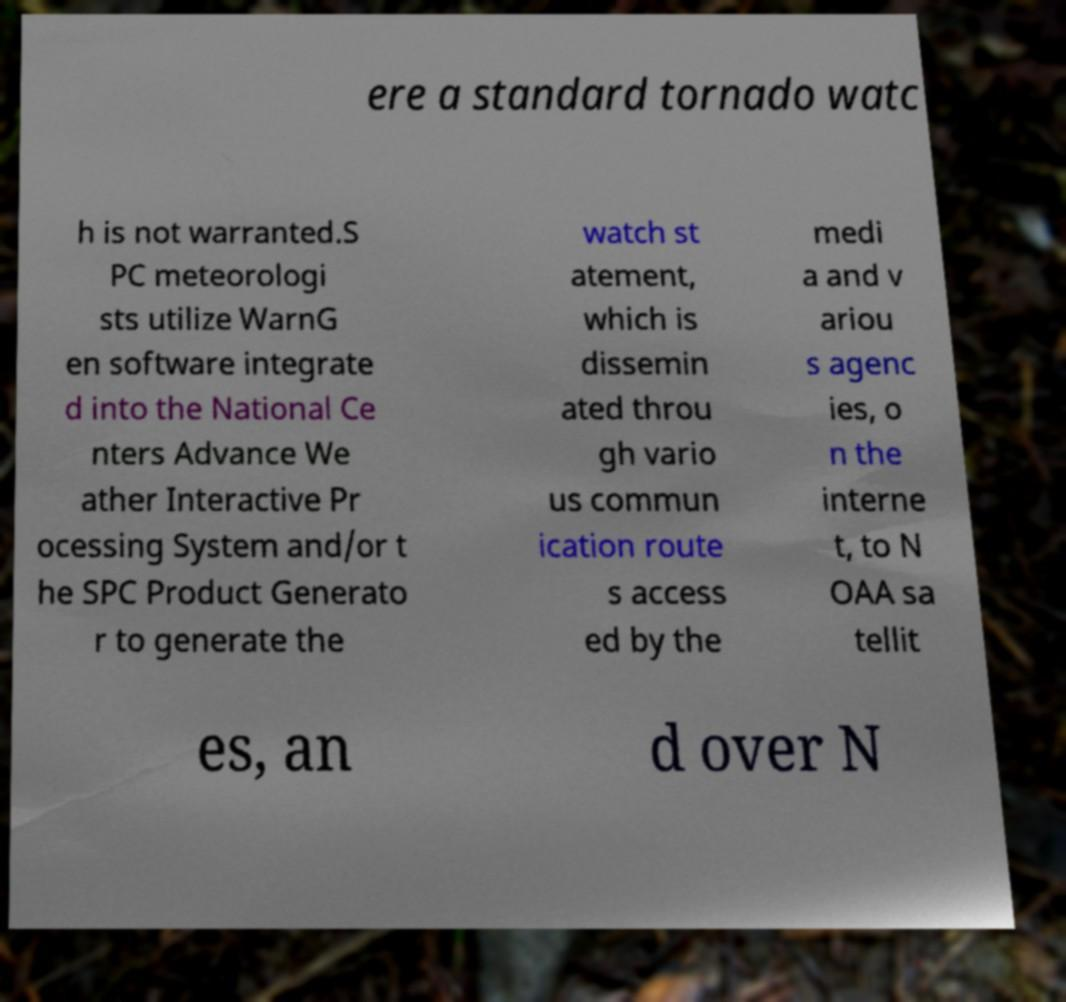Please identify and transcribe the text found in this image. ere a standard tornado watc h is not warranted.S PC meteorologi sts utilize WarnG en software integrate d into the National Ce nters Advance We ather Interactive Pr ocessing System and/or t he SPC Product Generato r to generate the watch st atement, which is dissemin ated throu gh vario us commun ication route s access ed by the medi a and v ariou s agenc ies, o n the interne t, to N OAA sa tellit es, an d over N 